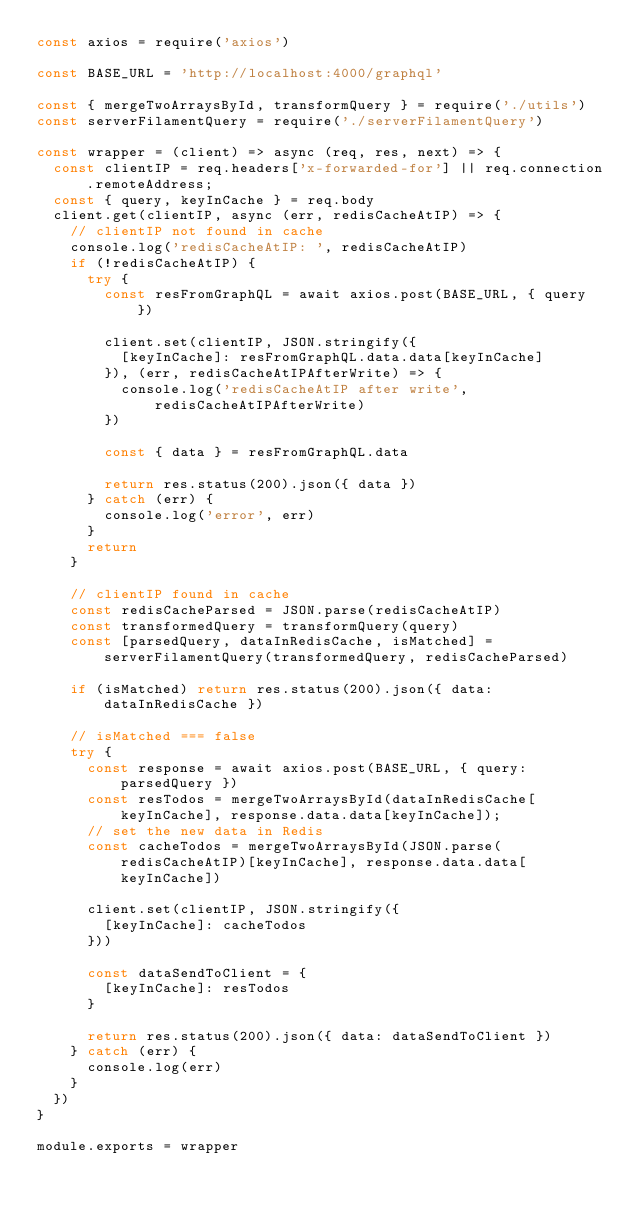<code> <loc_0><loc_0><loc_500><loc_500><_JavaScript_>const axios = require('axios')

const BASE_URL = 'http://localhost:4000/graphql'

const { mergeTwoArraysById, transformQuery } = require('./utils')
const serverFilamentQuery = require('./serverFilamentQuery')

const wrapper = (client) => async (req, res, next) => {
  const clientIP = req.headers['x-forwarded-for'] || req.connection.remoteAddress;
  const { query, keyInCache } = req.body
  client.get(clientIP, async (err, redisCacheAtIP) => {
    // clientIP not found in cache
    console.log('redisCacheAtIP: ', redisCacheAtIP)
    if (!redisCacheAtIP) {
      try {
        const resFromGraphQL = await axios.post(BASE_URL, { query })

        client.set(clientIP, JSON.stringify({
          [keyInCache]: resFromGraphQL.data.data[keyInCache]
        }), (err, redisCacheAtIPAfterWrite) => {
          console.log('redisCacheAtIP after write', redisCacheAtIPAfterWrite)
        })

        const { data } = resFromGraphQL.data

        return res.status(200).json({ data })
      } catch (err) {
        console.log('error', err)
      }
      return
    }

    // clientIP found in cache
    const redisCacheParsed = JSON.parse(redisCacheAtIP)
    const transformedQuery = transformQuery(query)
    const [parsedQuery, dataInRedisCache, isMatched] = serverFilamentQuery(transformedQuery, redisCacheParsed)

    if (isMatched) return res.status(200).json({ data: dataInRedisCache })

    // isMatched === false
    try {
      const response = await axios.post(BASE_URL, { query: parsedQuery })
      const resTodos = mergeTwoArraysById(dataInRedisCache[keyInCache], response.data.data[keyInCache]);
      // set the new data in Redis
      const cacheTodos = mergeTwoArraysById(JSON.parse(redisCacheAtIP)[keyInCache], response.data.data[keyInCache])

      client.set(clientIP, JSON.stringify({
        [keyInCache]: cacheTodos
      }))

      const dataSendToClient = {
        [keyInCache]: resTodos
      }

      return res.status(200).json({ data: dataSendToClient })
    } catch (err) {
      console.log(err)
    }
  })
}

module.exports = wrapper

</code> 